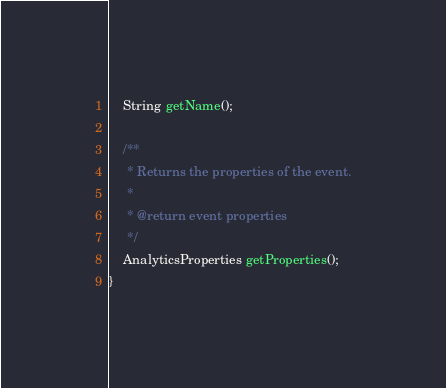<code> <loc_0><loc_0><loc_500><loc_500><_Java_>    String getName();

    /**
     * Returns the properties of the event.
     *
     * @return event properties
     */
    AnalyticsProperties getProperties();
}
</code> 